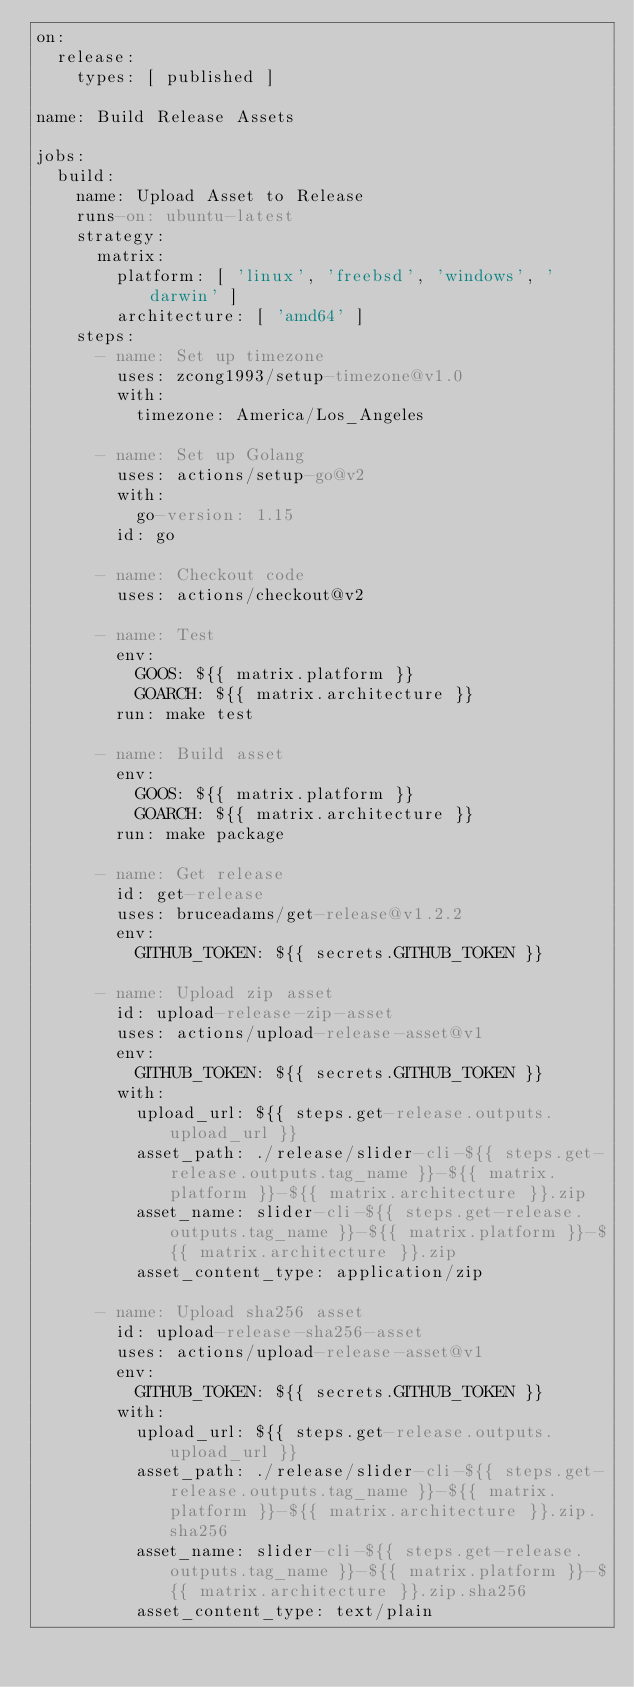<code> <loc_0><loc_0><loc_500><loc_500><_YAML_>on:
  release:
    types: [ published ]

name: Build Release Assets

jobs:
  build:
    name: Upload Asset to Release
    runs-on: ubuntu-latest
    strategy:
      matrix:
        platform: [ 'linux', 'freebsd', 'windows', 'darwin' ]
        architecture: [ 'amd64' ]
    steps:
      - name: Set up timezone
        uses: zcong1993/setup-timezone@v1.0
        with:
          timezone: America/Los_Angeles

      - name: Set up Golang
        uses: actions/setup-go@v2
        with:
          go-version: 1.15
        id: go

      - name: Checkout code
        uses: actions/checkout@v2

      - name: Test
        env:
          GOOS: ${{ matrix.platform }}
          GOARCH: ${{ matrix.architecture }}
        run: make test

      - name: Build asset
        env:
          GOOS: ${{ matrix.platform }}
          GOARCH: ${{ matrix.architecture }}
        run: make package

      - name: Get release
        id: get-release
        uses: bruceadams/get-release@v1.2.2
        env:
          GITHUB_TOKEN: ${{ secrets.GITHUB_TOKEN }}

      - name: Upload zip asset
        id: upload-release-zip-asset
        uses: actions/upload-release-asset@v1
        env:
          GITHUB_TOKEN: ${{ secrets.GITHUB_TOKEN }}
        with:
          upload_url: ${{ steps.get-release.outputs.upload_url }}
          asset_path: ./release/slider-cli-${{ steps.get-release.outputs.tag_name }}-${{ matrix.platform }}-${{ matrix.architecture }}.zip
          asset_name: slider-cli-${{ steps.get-release.outputs.tag_name }}-${{ matrix.platform }}-${{ matrix.architecture }}.zip
          asset_content_type: application/zip

      - name: Upload sha256 asset
        id: upload-release-sha256-asset
        uses: actions/upload-release-asset@v1
        env:
          GITHUB_TOKEN: ${{ secrets.GITHUB_TOKEN }}
        with:
          upload_url: ${{ steps.get-release.outputs.upload_url }}
          asset_path: ./release/slider-cli-${{ steps.get-release.outputs.tag_name }}-${{ matrix.platform }}-${{ matrix.architecture }}.zip.sha256
          asset_name: slider-cli-${{ steps.get-release.outputs.tag_name }}-${{ matrix.platform }}-${{ matrix.architecture }}.zip.sha256
          asset_content_type: text/plain</code> 